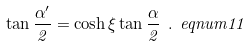Convert formula to latex. <formula><loc_0><loc_0><loc_500><loc_500>\tan \frac { \alpha ^ { \prime } } { 2 } = \cosh \xi \tan \frac { \alpha } { 2 } \ . \ e q n u m { 1 1 }</formula> 